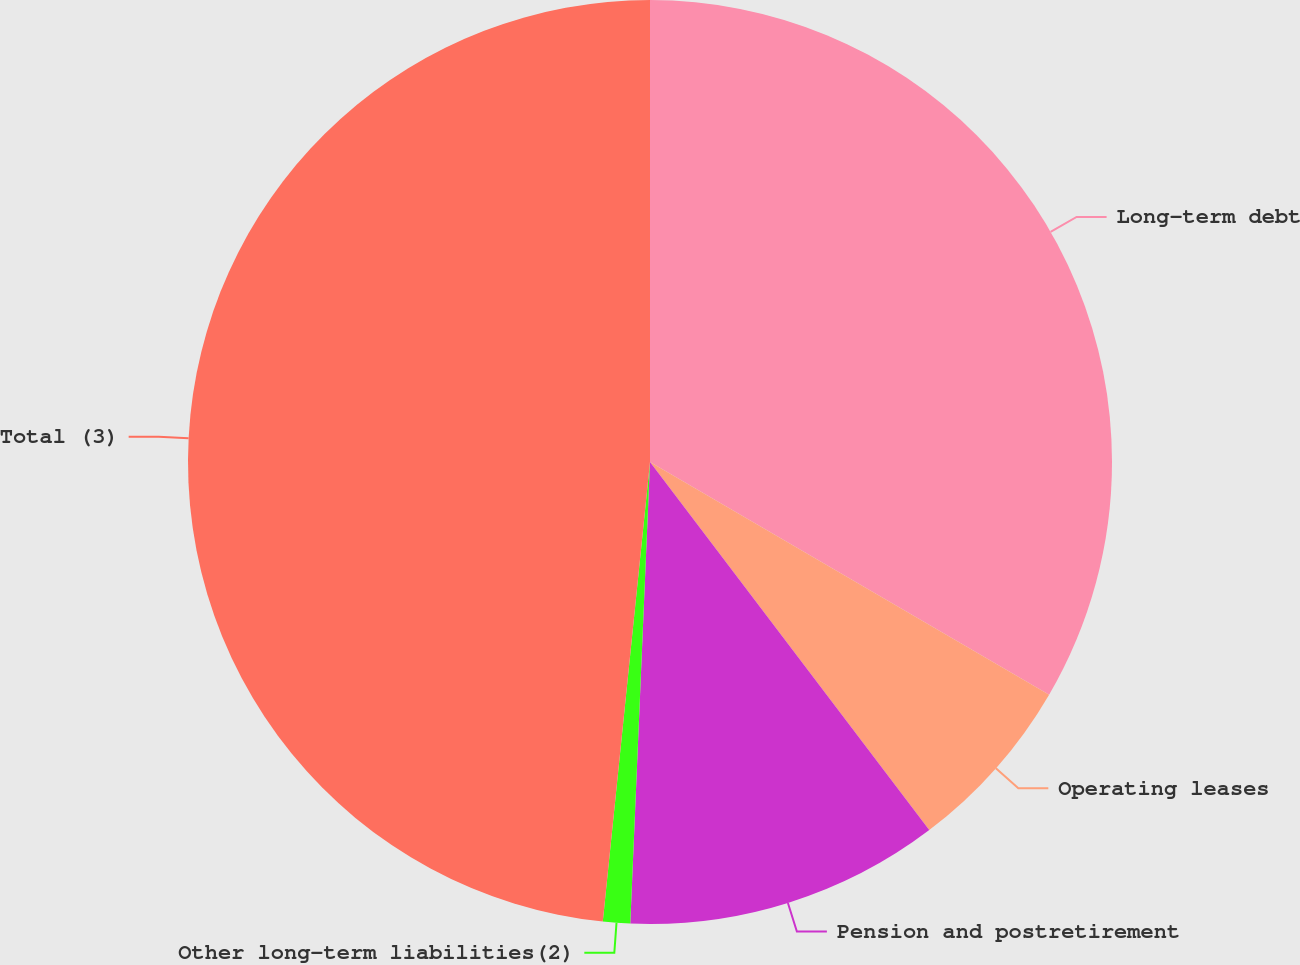<chart> <loc_0><loc_0><loc_500><loc_500><pie_chart><fcel>Long-term debt<fcel>Operating leases<fcel>Pension and postretirement<fcel>Other long-term liabilities(2)<fcel>Total (3)<nl><fcel>33.4%<fcel>6.27%<fcel>11.01%<fcel>0.95%<fcel>48.37%<nl></chart> 